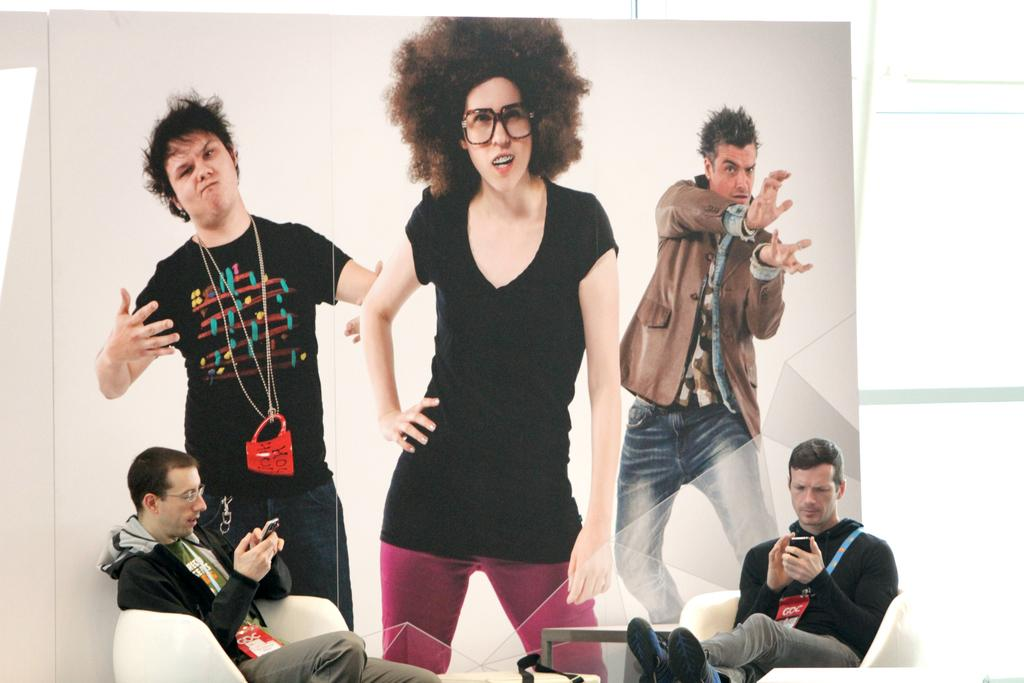How many people are present in the image? There are two men in the image. What are the men doing in the image? The men are sitting on chairs. What can be seen in the background of the image? There is a wall in the background of the image. What is depicted on the wall? There are posters of three people on the wall. How many clocks can be seen on the wall in the image? There are no clocks visible on the wall in the image. What direction are the men facing in the image? The provided facts do not specify the direction the men are facing, so it cannot be determined from the image. 